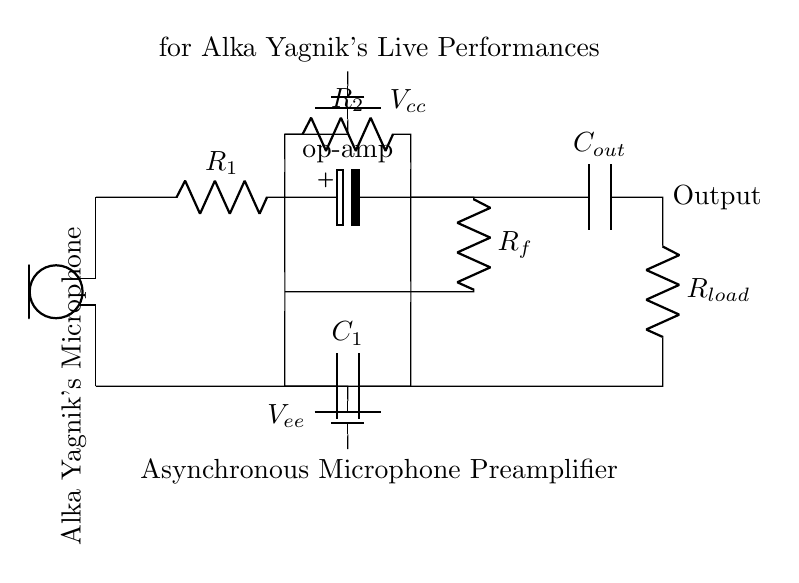What component captures Alka Yagnik's voice in this circuit? The microphone is the component responsible for capturing Alka Yagnik's voice, as it is marked in the circuit diagram.
Answer: Microphone What does R1 represent in this circuit? R1 is a resistor that is part of the preamplifier stage, providing necessary resistance in the amplification process.
Answer: Resistor What is the function of the op-amp in this circuit? The operational amplifier (op-amp) amplifies the small audio signal from the microphone, which is essential for boosting the signal to a usable level.
Answer: Amplification Which component is responsible for filtering the output signal? The output capacitor (Cout) filters the output signal, allowing only the desired frequency range to pass through while blocking unwanted noise.
Answer: Capacitor What type of amplifier is used in this circuit? The circuit is an asynchronous microphone preamplifier, which means it converts the microphone's analog signal into a stronger analog signal without requiring a synchronous input signal.
Answer: Asynchronous How is the power supplied to the circuit? The power supply is provided by two batteries, one labeled Vcc and the other Vee, which provide positive and negative voltage rails for the circuit's operation.
Answer: Batteries 